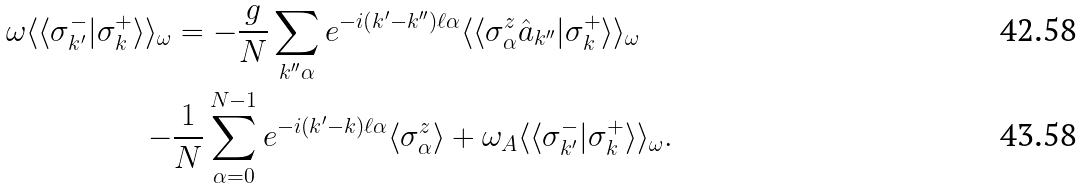Convert formula to latex. <formula><loc_0><loc_0><loc_500><loc_500>\omega \langle \langle \sigma _ { k ^ { \prime } } ^ { - } | \sigma _ { k } ^ { + } \rangle \rangle _ { \omega } & = - \frac { g } { N } \sum _ { k ^ { \prime \prime } \alpha } e ^ { - i ( k ^ { \prime } - k ^ { \prime \prime } ) \ell \alpha } \langle \langle \sigma _ { \alpha } ^ { z } \hat { a } _ { k ^ { \prime \prime } } | \sigma _ { k } ^ { + } \rangle \rangle _ { \omega } \\ - & \frac { 1 } { N } \sum _ { \alpha = 0 } ^ { N - 1 } e ^ { - i ( k ^ { \prime } - k ) \ell \alpha } \langle \sigma _ { \alpha } ^ { z } \rangle + \omega _ { A } \langle \langle \sigma _ { k ^ { \prime } } ^ { - } | \sigma _ { k } ^ { + } \rangle \rangle _ { \omega } .</formula> 